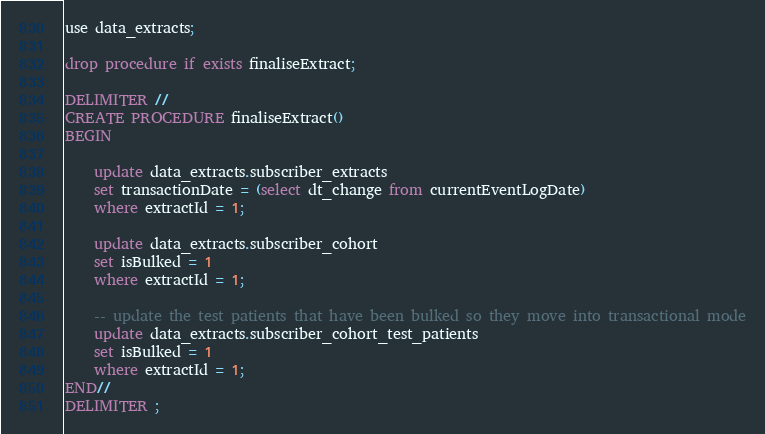Convert code to text. <code><loc_0><loc_0><loc_500><loc_500><_SQL_>use data_extracts;

drop procedure if exists finaliseExtract;

DELIMITER //
CREATE PROCEDURE finaliseExtract()
BEGIN	
    
    update data_extracts.subscriber_extracts 
    set transactionDate = (select dt_change from currentEventLogDate) 
    where extractId = 1;
    
    update data_extracts.subscriber_cohort
    set isBulked = 1
    where extractId = 1;
	
	-- update the test patients that have been bulked so they move into transactional mode
	update data_extracts.subscriber_cohort_test_patients
    set isBulked = 1
    where extractId = 1;
END//
DELIMITER ;</code> 